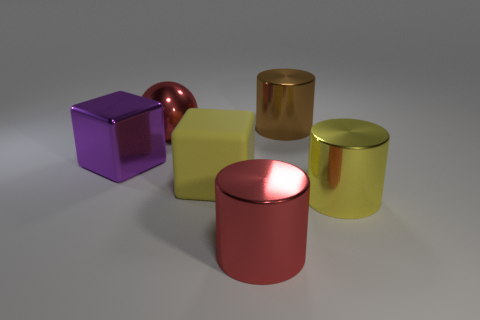Add 4 big blue shiny spheres. How many objects exist? 10 Subtract all balls. How many objects are left? 5 Subtract all large yellow cylinders. Subtract all purple things. How many objects are left? 4 Add 5 brown cylinders. How many brown cylinders are left? 6 Add 5 red metallic cylinders. How many red metallic cylinders exist? 6 Subtract 0 blue cubes. How many objects are left? 6 